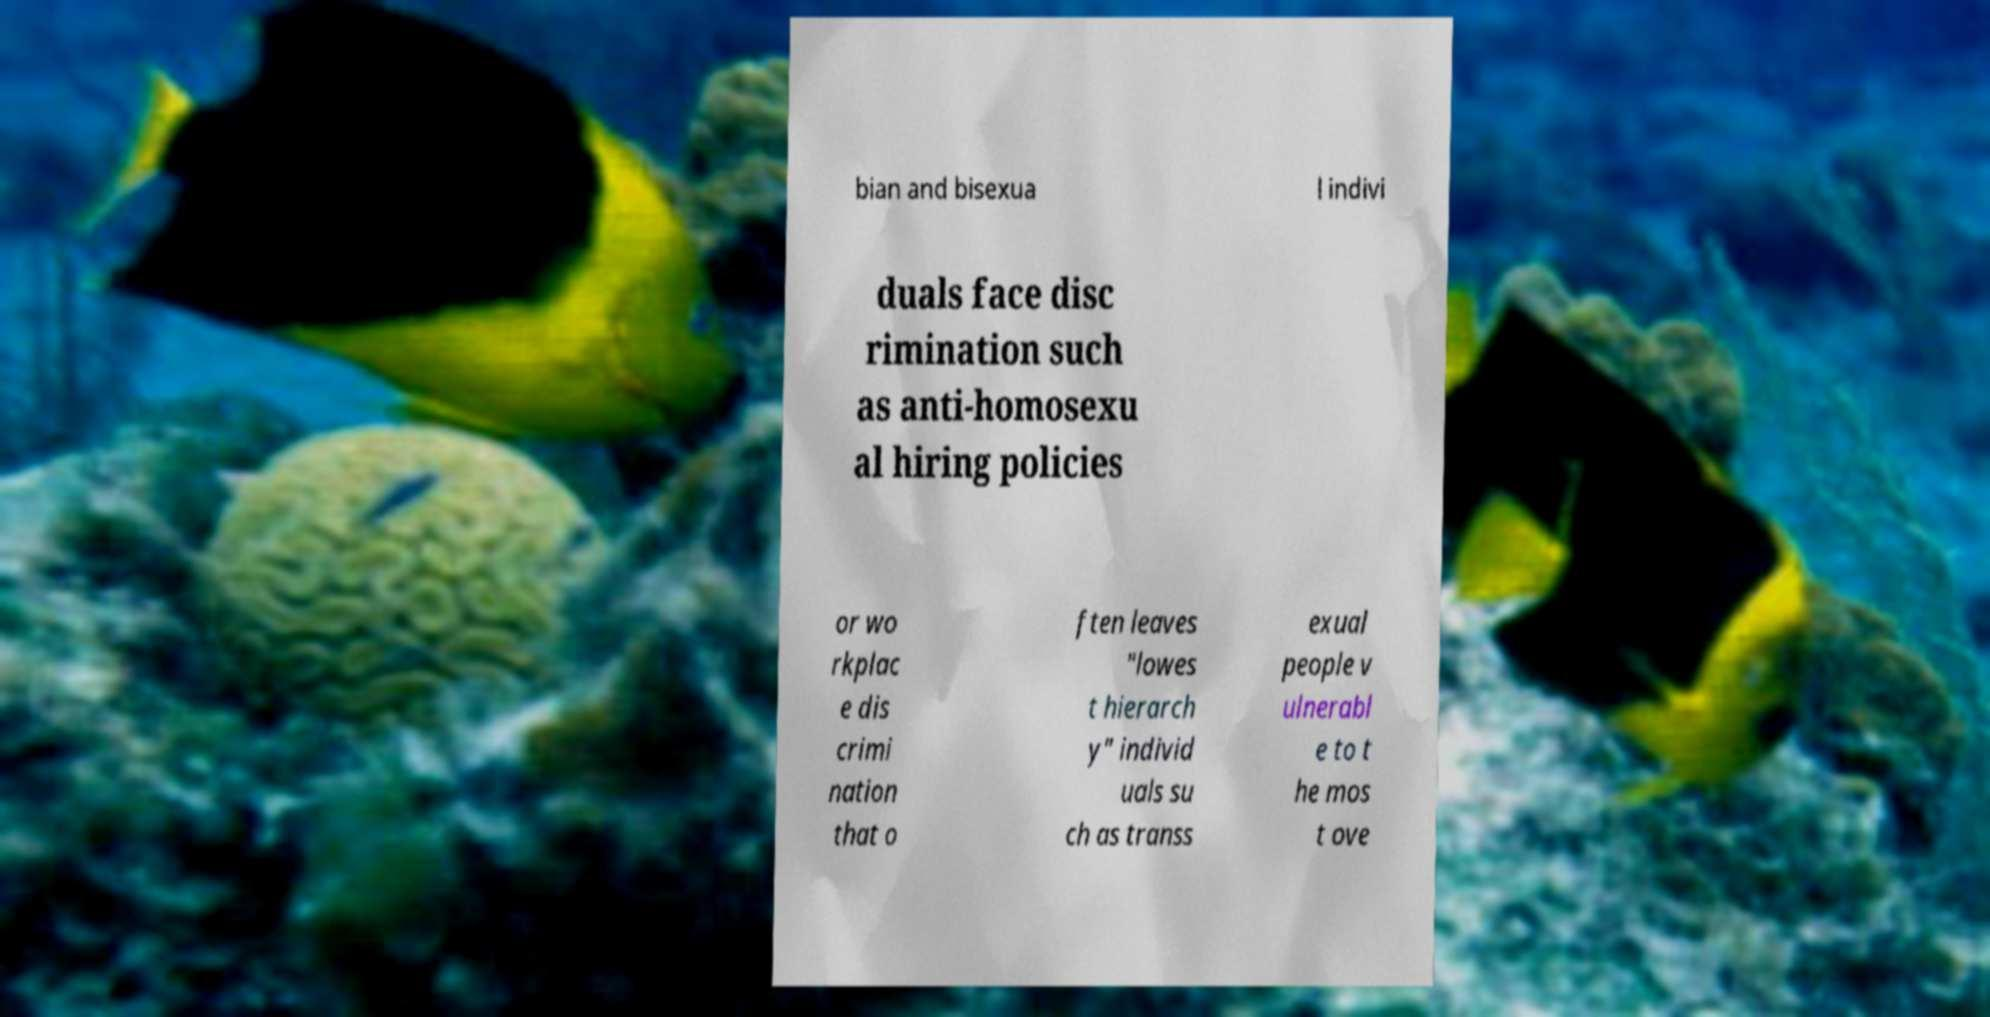I need the written content from this picture converted into text. Can you do that? bian and bisexua l indivi duals face disc rimination such as anti-homosexu al hiring policies or wo rkplac e dis crimi nation that o ften leaves "lowes t hierarch y" individ uals su ch as transs exual people v ulnerabl e to t he mos t ove 